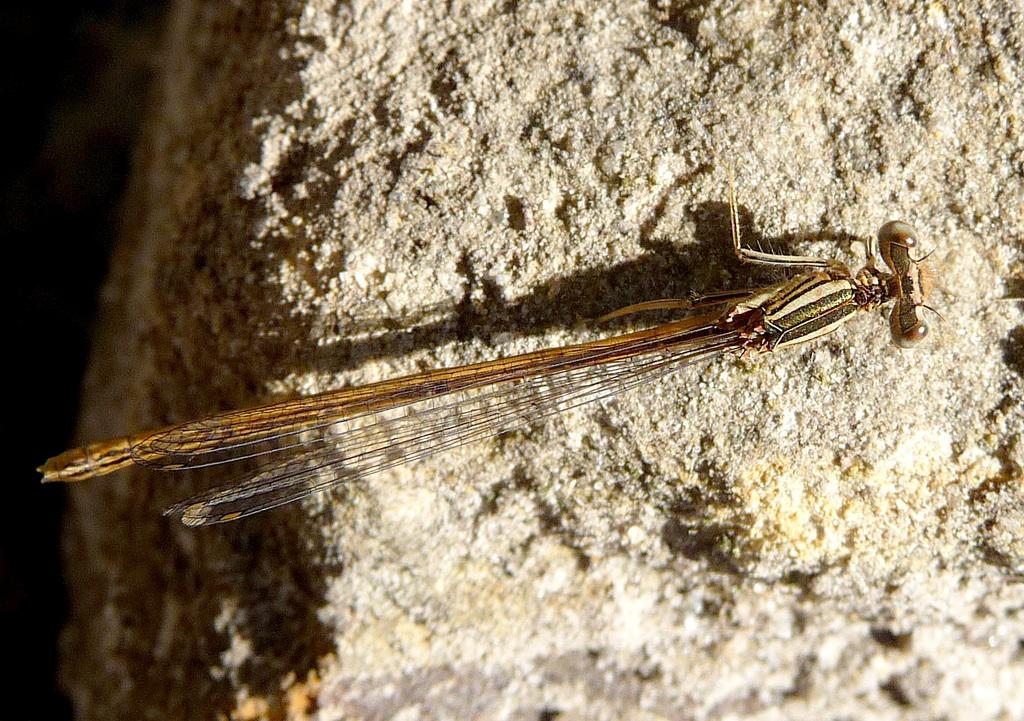What is the main subject in the center of the image? There is a dragonfly in the center of the image. What can be seen in the background of the image? There is a rock in the background of the image. What type of hammer is being used by the dragonfly in the image? There is no hammer present in the image; it features a dragonfly and a rock. How many feet can be seen on the dragonfly in the image? Dragonflies do not have feet like mammals; they have six legs, but they are not visible in the image. 